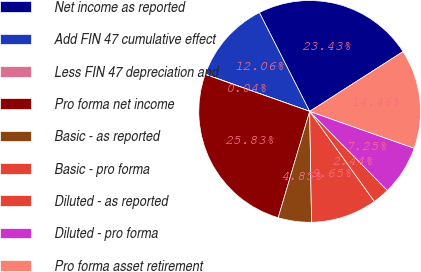<chart> <loc_0><loc_0><loc_500><loc_500><pie_chart><fcel>Net income as reported<fcel>Add FIN 47 cumulative effect<fcel>Less FIN 47 depreciation and<fcel>Pro forma net income<fcel>Basic - as reported<fcel>Basic - pro forma<fcel>Diluted - as reported<fcel>Diluted - pro forma<fcel>Pro forma asset retirement<nl><fcel>23.43%<fcel>12.06%<fcel>0.04%<fcel>25.83%<fcel>4.85%<fcel>9.65%<fcel>2.44%<fcel>7.25%<fcel>14.46%<nl></chart> 